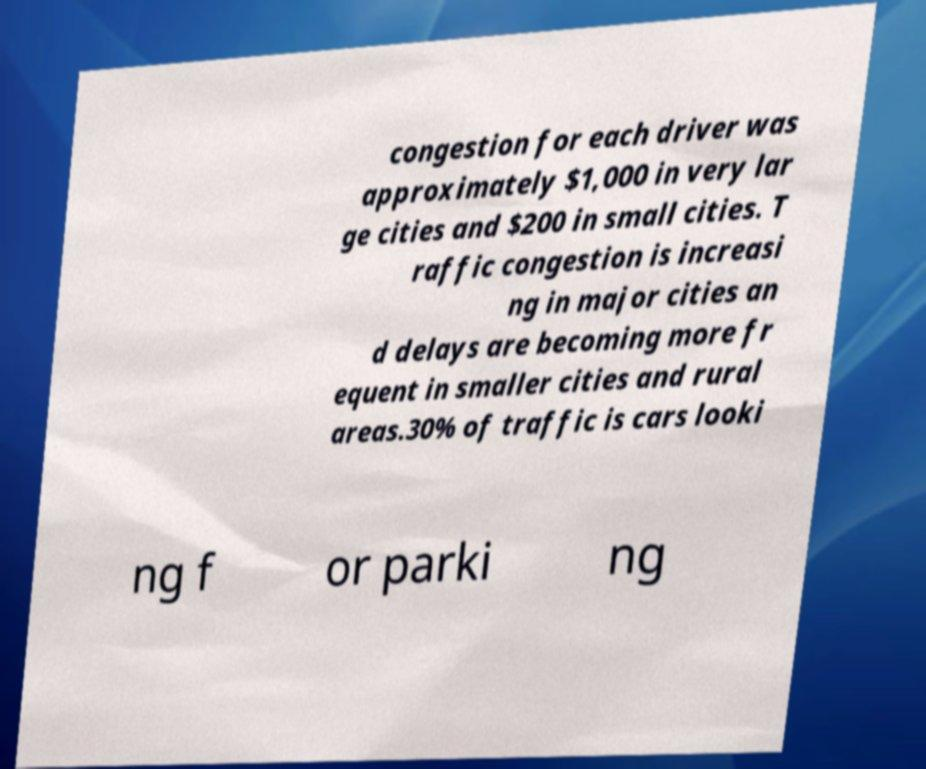What messages or text are displayed in this image? I need them in a readable, typed format. congestion for each driver was approximately $1,000 in very lar ge cities and $200 in small cities. T raffic congestion is increasi ng in major cities an d delays are becoming more fr equent in smaller cities and rural areas.30% of traffic is cars looki ng f or parki ng 